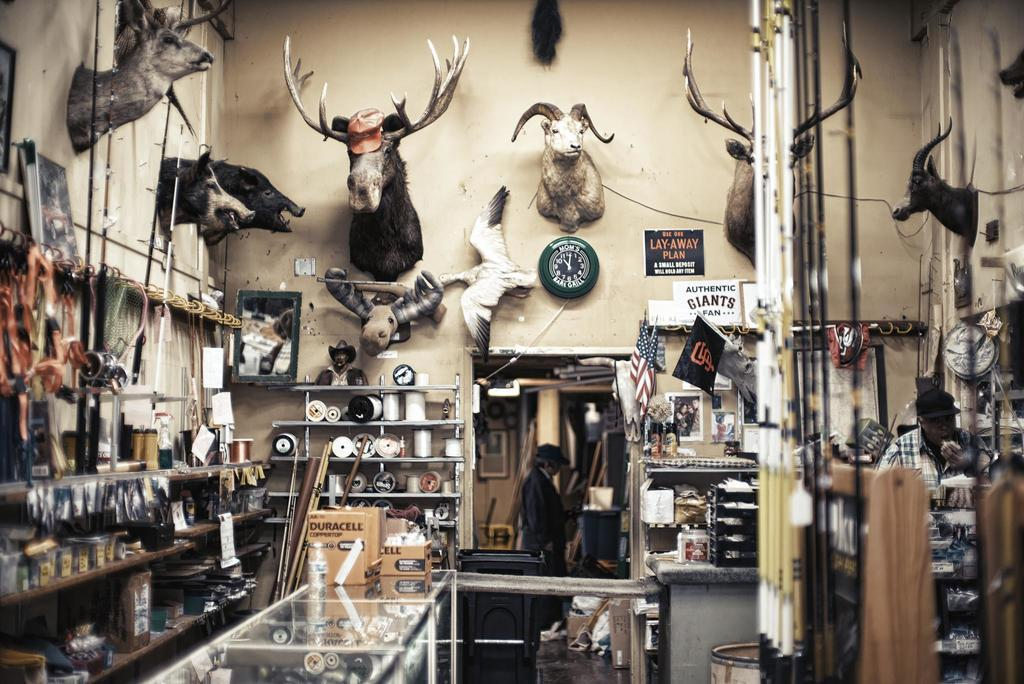<image>
Offer a succinct explanation of the picture presented. a Giants logo is above the room with many items 